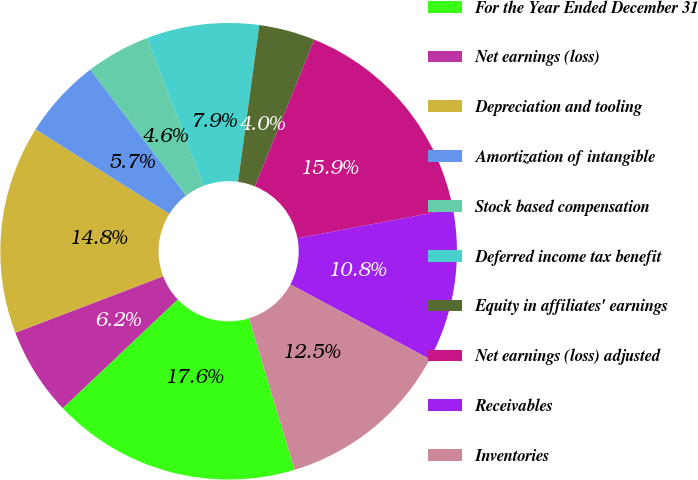Convert chart to OTSL. <chart><loc_0><loc_0><loc_500><loc_500><pie_chart><fcel>For the Year Ended December 31<fcel>Net earnings (loss)<fcel>Depreciation and tooling<fcel>Amortization of intangible<fcel>Stock based compensation<fcel>Deferred income tax benefit<fcel>Equity in affiliates' earnings<fcel>Net earnings (loss) adjusted<fcel>Receivables<fcel>Inventories<nl><fcel>17.61%<fcel>6.25%<fcel>14.77%<fcel>5.68%<fcel>4.55%<fcel>7.95%<fcel>3.98%<fcel>15.91%<fcel>10.8%<fcel>12.5%<nl></chart> 